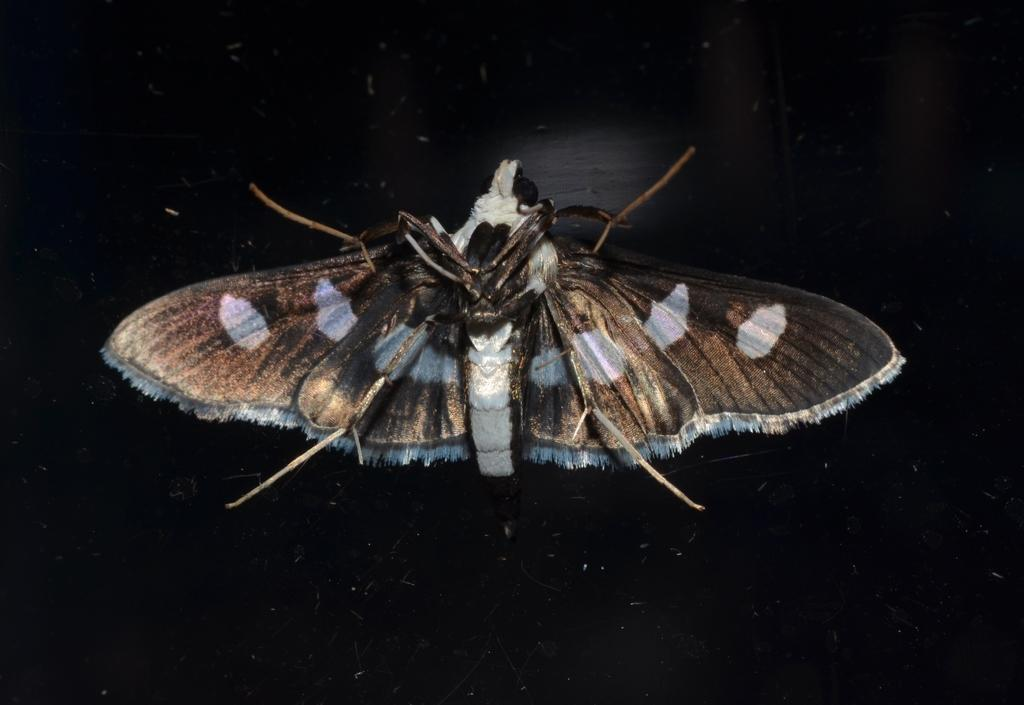What type of creature can be seen in the image? There is an insect in the image. Where is the insect situated? The insect is present on a surface. Can you describe the insect's position in the image? The insect is located in the center of the image. What type of bomb can be seen in the image? There is no bomb present in the image; it features an insect on a surface. How is the glue used in the image? There is no glue present in the image. 